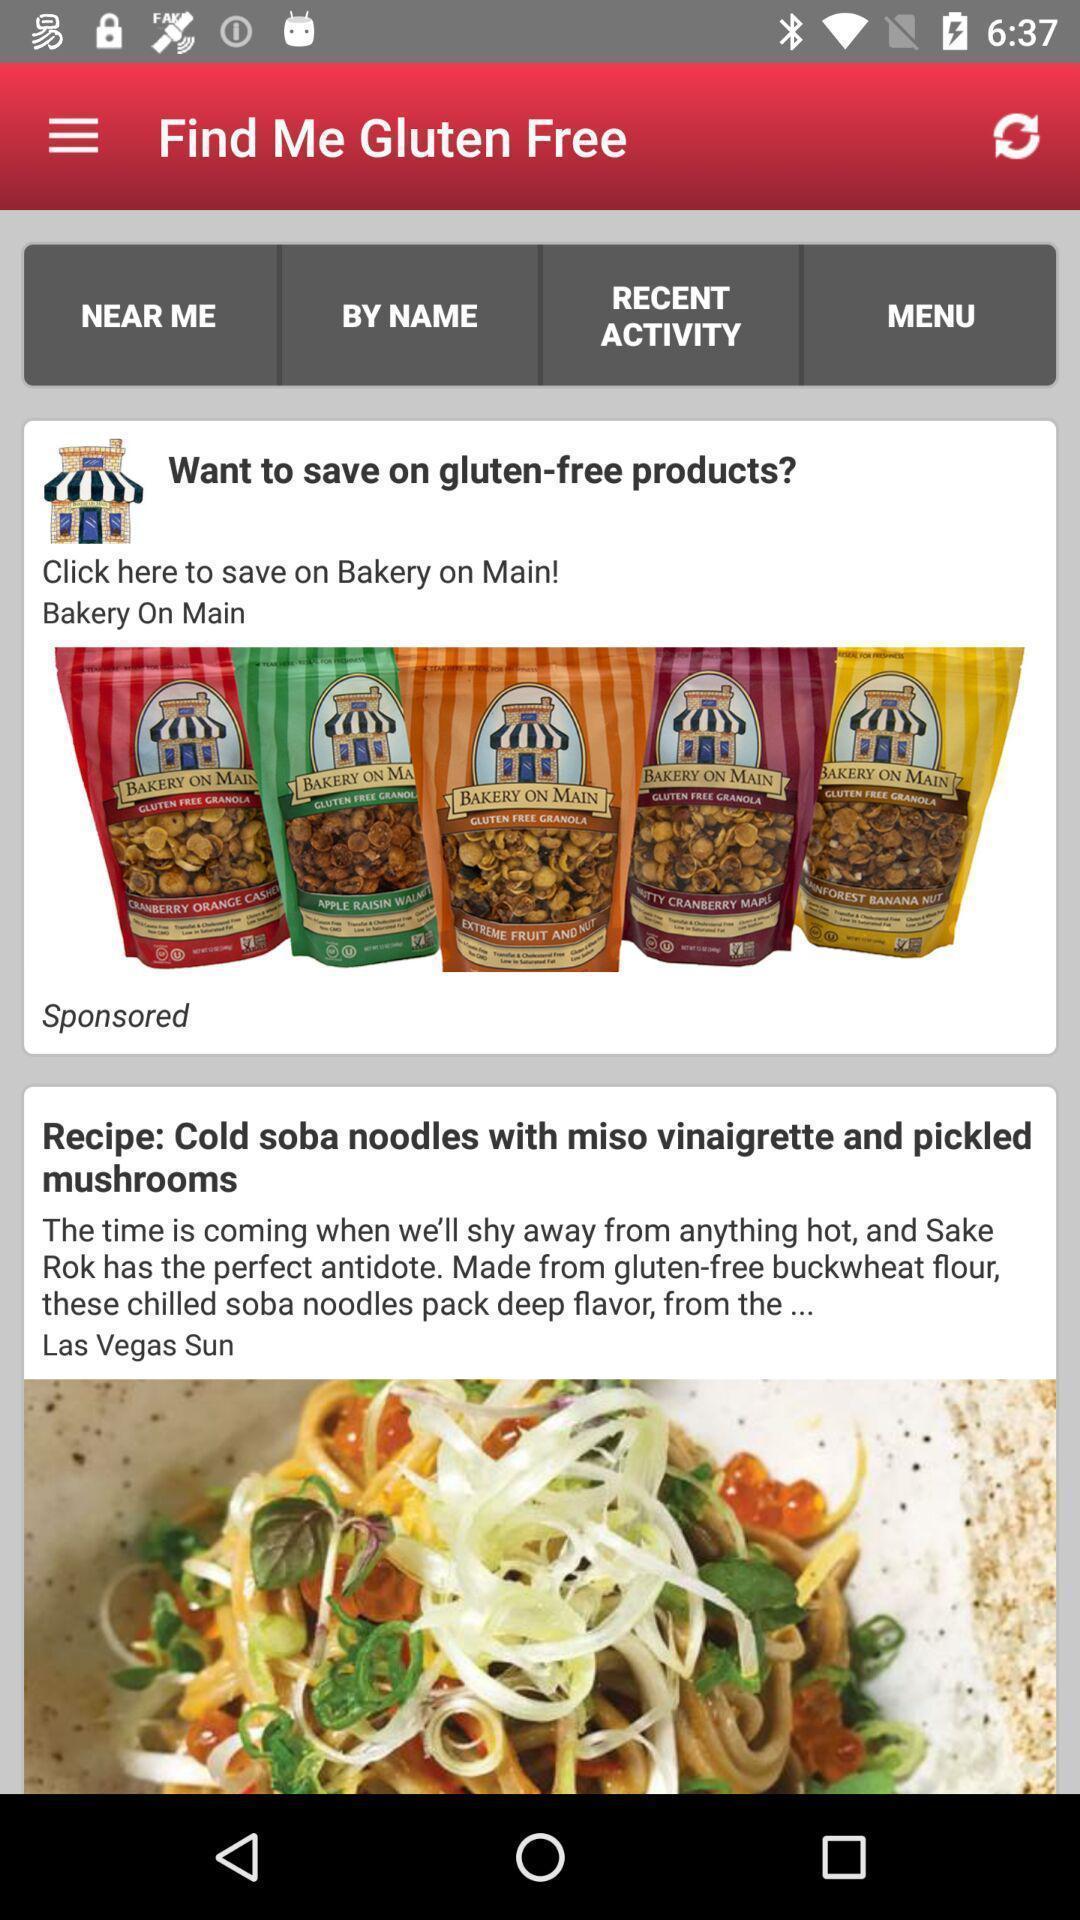Summarize the information in this screenshot. Screen displaying the gluten free products. 